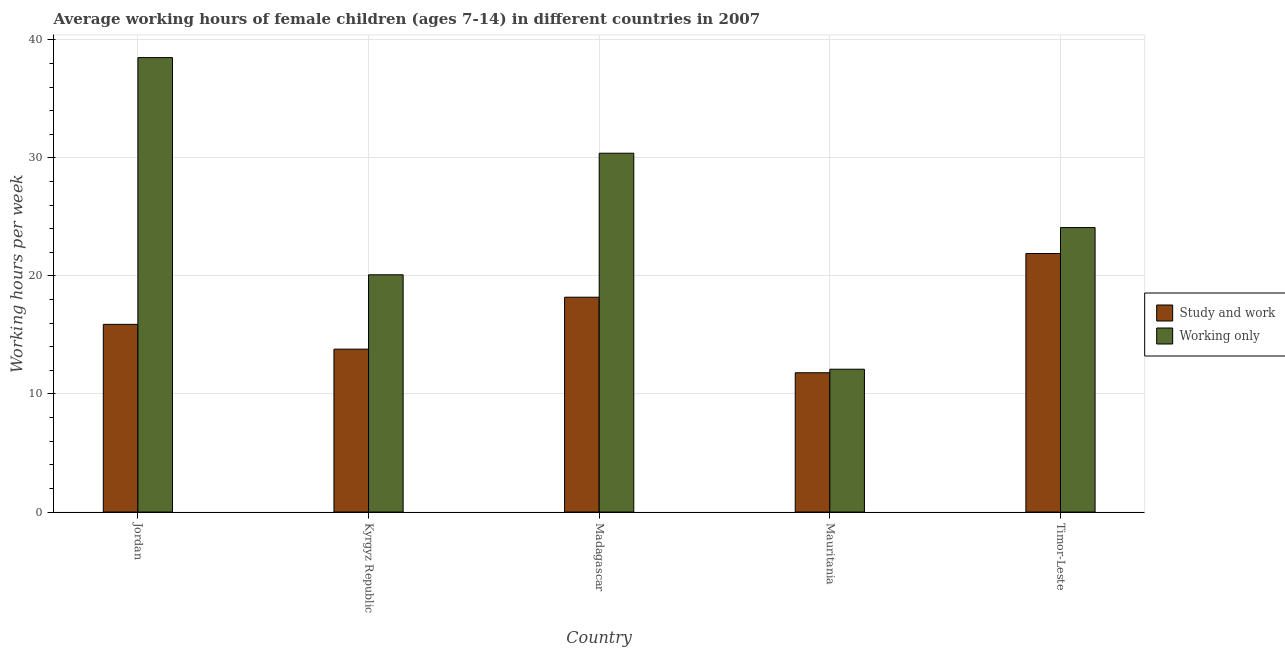How many groups of bars are there?
Offer a very short reply. 5. Are the number of bars on each tick of the X-axis equal?
Ensure brevity in your answer.  Yes. How many bars are there on the 5th tick from the right?
Make the answer very short. 2. What is the label of the 4th group of bars from the left?
Provide a short and direct response. Mauritania. In how many cases, is the number of bars for a given country not equal to the number of legend labels?
Your answer should be very brief. 0. Across all countries, what is the maximum average working hour of children involved in study and work?
Your answer should be very brief. 21.9. In which country was the average working hour of children involved in only work maximum?
Offer a very short reply. Jordan. In which country was the average working hour of children involved in only work minimum?
Provide a short and direct response. Mauritania. What is the total average working hour of children involved in study and work in the graph?
Ensure brevity in your answer.  81.6. What is the difference between the average working hour of children involved in study and work in Jordan and that in Timor-Leste?
Ensure brevity in your answer.  -6. What is the difference between the average working hour of children involved in only work in Timor-Leste and the average working hour of children involved in study and work in Jordan?
Offer a terse response. 8.2. What is the average average working hour of children involved in only work per country?
Offer a very short reply. 25.04. In how many countries, is the average working hour of children involved in only work greater than 14 hours?
Your response must be concise. 4. What is the ratio of the average working hour of children involved in study and work in Kyrgyz Republic to that in Mauritania?
Give a very brief answer. 1.17. Is the difference between the average working hour of children involved in only work in Jordan and Madagascar greater than the difference between the average working hour of children involved in study and work in Jordan and Madagascar?
Keep it short and to the point. Yes. What is the difference between the highest and the second highest average working hour of children involved in only work?
Offer a very short reply. 8.1. What is the difference between the highest and the lowest average working hour of children involved in only work?
Ensure brevity in your answer.  26.4. What does the 1st bar from the left in Mauritania represents?
Ensure brevity in your answer.  Study and work. What does the 1st bar from the right in Madagascar represents?
Ensure brevity in your answer.  Working only. How many bars are there?
Provide a short and direct response. 10. Are all the bars in the graph horizontal?
Offer a very short reply. No. How many countries are there in the graph?
Make the answer very short. 5. What is the difference between two consecutive major ticks on the Y-axis?
Give a very brief answer. 10. Does the graph contain grids?
Give a very brief answer. Yes. Where does the legend appear in the graph?
Offer a terse response. Center right. How many legend labels are there?
Offer a very short reply. 2. What is the title of the graph?
Offer a terse response. Average working hours of female children (ages 7-14) in different countries in 2007. Does "Highest 10% of population" appear as one of the legend labels in the graph?
Your answer should be very brief. No. What is the label or title of the X-axis?
Your answer should be very brief. Country. What is the label or title of the Y-axis?
Provide a short and direct response. Working hours per week. What is the Working hours per week in Study and work in Jordan?
Offer a very short reply. 15.9. What is the Working hours per week of Working only in Jordan?
Offer a very short reply. 38.5. What is the Working hours per week in Working only in Kyrgyz Republic?
Ensure brevity in your answer.  20.1. What is the Working hours per week in Study and work in Madagascar?
Your response must be concise. 18.2. What is the Working hours per week of Working only in Madagascar?
Your answer should be very brief. 30.4. What is the Working hours per week in Study and work in Mauritania?
Make the answer very short. 11.8. What is the Working hours per week in Working only in Mauritania?
Keep it short and to the point. 12.1. What is the Working hours per week of Study and work in Timor-Leste?
Offer a terse response. 21.9. What is the Working hours per week in Working only in Timor-Leste?
Keep it short and to the point. 24.1. Across all countries, what is the maximum Working hours per week of Study and work?
Provide a short and direct response. 21.9. Across all countries, what is the maximum Working hours per week in Working only?
Your answer should be very brief. 38.5. Across all countries, what is the minimum Working hours per week in Study and work?
Your answer should be very brief. 11.8. Across all countries, what is the minimum Working hours per week of Working only?
Make the answer very short. 12.1. What is the total Working hours per week of Study and work in the graph?
Offer a very short reply. 81.6. What is the total Working hours per week of Working only in the graph?
Your response must be concise. 125.2. What is the difference between the Working hours per week of Working only in Jordan and that in Kyrgyz Republic?
Provide a short and direct response. 18.4. What is the difference between the Working hours per week of Study and work in Jordan and that in Madagascar?
Provide a succinct answer. -2.3. What is the difference between the Working hours per week of Study and work in Jordan and that in Mauritania?
Your answer should be compact. 4.1. What is the difference between the Working hours per week of Working only in Jordan and that in Mauritania?
Your answer should be very brief. 26.4. What is the difference between the Working hours per week in Study and work in Jordan and that in Timor-Leste?
Provide a short and direct response. -6. What is the difference between the Working hours per week in Working only in Kyrgyz Republic and that in Madagascar?
Your response must be concise. -10.3. What is the difference between the Working hours per week in Study and work in Kyrgyz Republic and that in Timor-Leste?
Offer a very short reply. -8.1. What is the difference between the Working hours per week of Study and work in Madagascar and that in Mauritania?
Offer a very short reply. 6.4. What is the difference between the Working hours per week of Working only in Madagascar and that in Mauritania?
Ensure brevity in your answer.  18.3. What is the difference between the Working hours per week of Study and work in Jordan and the Working hours per week of Working only in Kyrgyz Republic?
Your answer should be compact. -4.2. What is the difference between the Working hours per week in Study and work in Jordan and the Working hours per week in Working only in Mauritania?
Give a very brief answer. 3.8. What is the difference between the Working hours per week of Study and work in Jordan and the Working hours per week of Working only in Timor-Leste?
Keep it short and to the point. -8.2. What is the difference between the Working hours per week in Study and work in Kyrgyz Republic and the Working hours per week in Working only in Madagascar?
Offer a terse response. -16.6. What is the difference between the Working hours per week in Study and work in Kyrgyz Republic and the Working hours per week in Working only in Timor-Leste?
Provide a succinct answer. -10.3. What is the difference between the Working hours per week of Study and work in Mauritania and the Working hours per week of Working only in Timor-Leste?
Your response must be concise. -12.3. What is the average Working hours per week in Study and work per country?
Ensure brevity in your answer.  16.32. What is the average Working hours per week of Working only per country?
Give a very brief answer. 25.04. What is the difference between the Working hours per week of Study and work and Working hours per week of Working only in Jordan?
Keep it short and to the point. -22.6. What is the difference between the Working hours per week of Study and work and Working hours per week of Working only in Mauritania?
Provide a short and direct response. -0.3. What is the difference between the Working hours per week in Study and work and Working hours per week in Working only in Timor-Leste?
Keep it short and to the point. -2.2. What is the ratio of the Working hours per week in Study and work in Jordan to that in Kyrgyz Republic?
Make the answer very short. 1.15. What is the ratio of the Working hours per week in Working only in Jordan to that in Kyrgyz Republic?
Provide a short and direct response. 1.92. What is the ratio of the Working hours per week in Study and work in Jordan to that in Madagascar?
Provide a succinct answer. 0.87. What is the ratio of the Working hours per week of Working only in Jordan to that in Madagascar?
Your answer should be very brief. 1.27. What is the ratio of the Working hours per week of Study and work in Jordan to that in Mauritania?
Provide a short and direct response. 1.35. What is the ratio of the Working hours per week of Working only in Jordan to that in Mauritania?
Make the answer very short. 3.18. What is the ratio of the Working hours per week of Study and work in Jordan to that in Timor-Leste?
Offer a very short reply. 0.73. What is the ratio of the Working hours per week of Working only in Jordan to that in Timor-Leste?
Ensure brevity in your answer.  1.6. What is the ratio of the Working hours per week in Study and work in Kyrgyz Republic to that in Madagascar?
Provide a short and direct response. 0.76. What is the ratio of the Working hours per week of Working only in Kyrgyz Republic to that in Madagascar?
Give a very brief answer. 0.66. What is the ratio of the Working hours per week of Study and work in Kyrgyz Republic to that in Mauritania?
Give a very brief answer. 1.17. What is the ratio of the Working hours per week in Working only in Kyrgyz Republic to that in Mauritania?
Ensure brevity in your answer.  1.66. What is the ratio of the Working hours per week in Study and work in Kyrgyz Republic to that in Timor-Leste?
Provide a short and direct response. 0.63. What is the ratio of the Working hours per week of Working only in Kyrgyz Republic to that in Timor-Leste?
Offer a very short reply. 0.83. What is the ratio of the Working hours per week in Study and work in Madagascar to that in Mauritania?
Provide a short and direct response. 1.54. What is the ratio of the Working hours per week in Working only in Madagascar to that in Mauritania?
Your response must be concise. 2.51. What is the ratio of the Working hours per week of Study and work in Madagascar to that in Timor-Leste?
Your answer should be compact. 0.83. What is the ratio of the Working hours per week in Working only in Madagascar to that in Timor-Leste?
Offer a terse response. 1.26. What is the ratio of the Working hours per week of Study and work in Mauritania to that in Timor-Leste?
Your answer should be very brief. 0.54. What is the ratio of the Working hours per week in Working only in Mauritania to that in Timor-Leste?
Your response must be concise. 0.5. What is the difference between the highest and the second highest Working hours per week of Study and work?
Provide a short and direct response. 3.7. What is the difference between the highest and the lowest Working hours per week in Study and work?
Ensure brevity in your answer.  10.1. What is the difference between the highest and the lowest Working hours per week of Working only?
Offer a terse response. 26.4. 